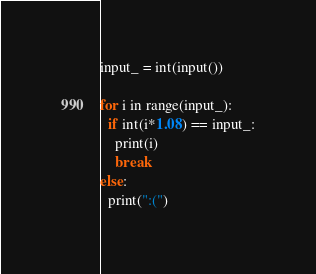Convert code to text. <code><loc_0><loc_0><loc_500><loc_500><_Python_>input_ = int(input())

for i in range(input_):
  if int(i*1.08) == input_:
    print(i)
    break
else:
  print(":(")</code> 